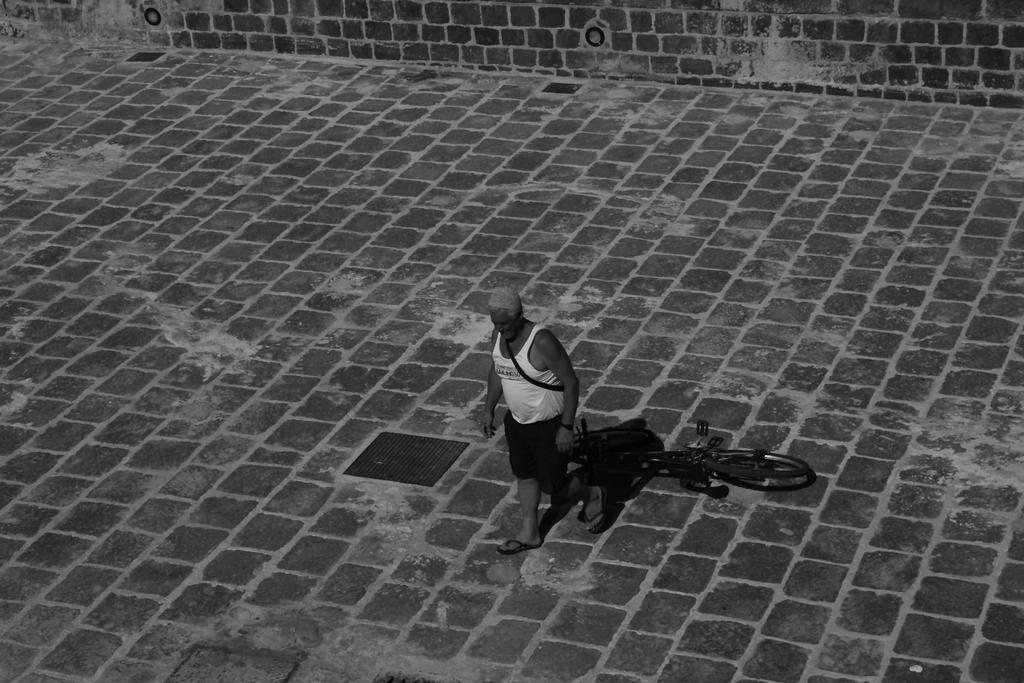Who or what is the main subject in the center of the image? There is a person in the center of the image. What object is located beside the person? There is a cycle beside the person. What type of path is visible at the bottom of the image? There is a walkway at the bottom of the image. What can be seen in the background of the image? There is a wall in the background of the image. What type of jam is being spread on the wall in the image? There is no jam present in the image, and the wall does not appear to be interacted with in any way. 